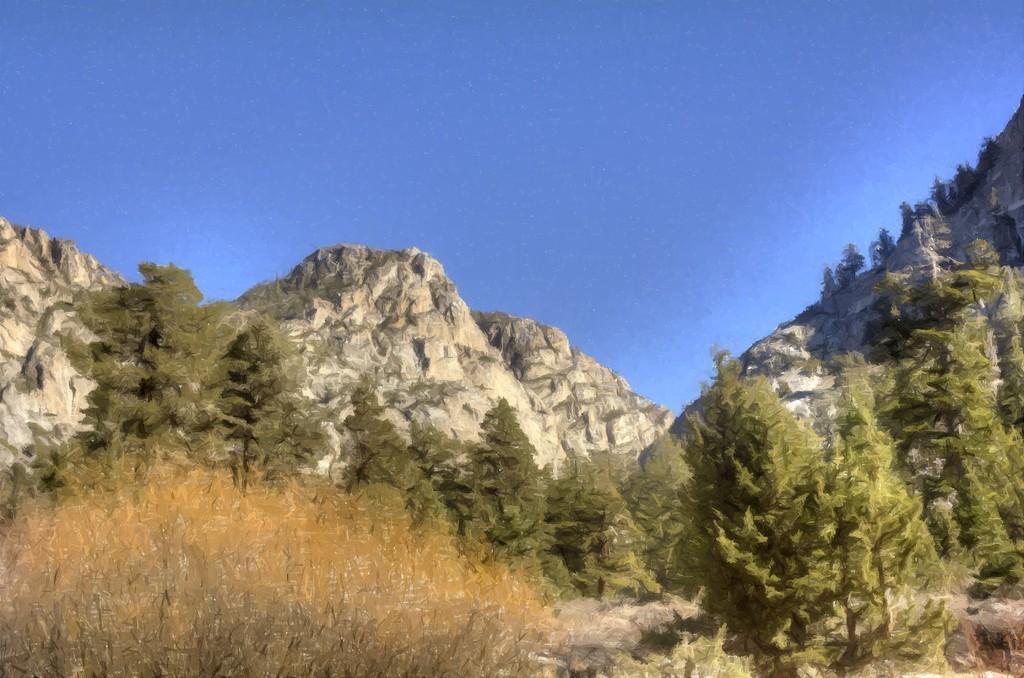Please provide a concise description of this image. This image is taken outdoors. At the top of the image there is a sky. At the bottom of the image there are a few plants and many trees. In the background there are a few hills. 